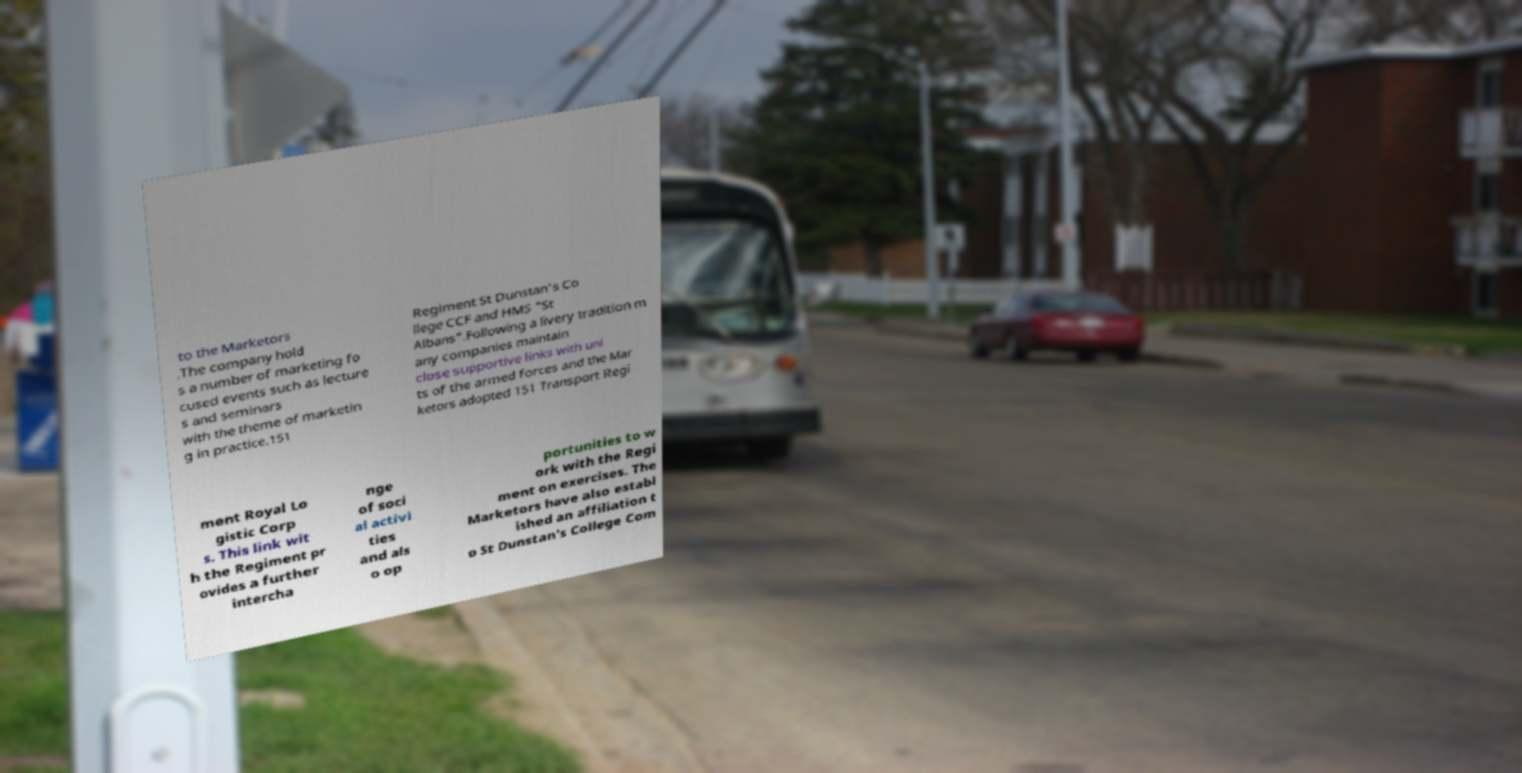Please identify and transcribe the text found in this image. to the Marketors .The company hold s a number of marketing fo cused events such as lecture s and seminars with the theme of marketin g in practice.151 Regiment St Dunstan's Co llege CCF and HMS "St Albans".Following a livery tradition m any companies maintain close supportive links with uni ts of the armed forces and the Mar ketors adopted 151 Transport Regi ment Royal Lo gistic Corp s. This link wit h the Regiment pr ovides a further intercha nge of soci al activi ties and als o op portunities to w ork with the Regi ment on exercises. The Marketors have also establ ished an affiliation t o St Dunstan's College Com 